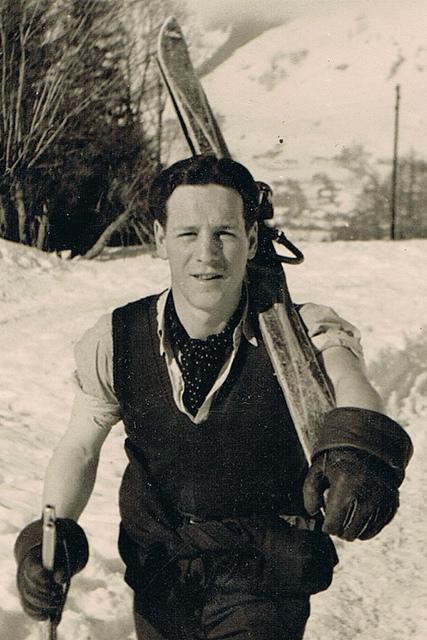How many ski are visible?
Give a very brief answer. 1. How many sandwiches are on the plate?
Give a very brief answer. 0. 